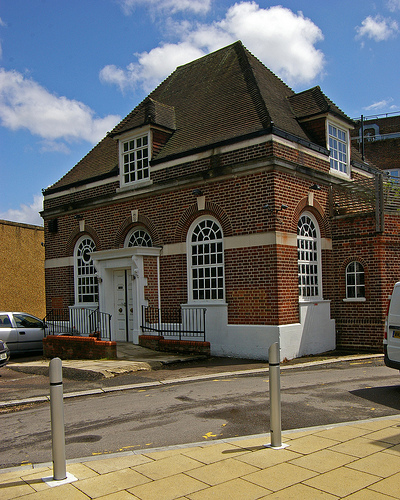<image>
Is the car in front of the building? Yes. The car is positioned in front of the building, appearing closer to the camera viewpoint. Where is the china glass in relation to the wood build? Is it in front of the wood build? No. The china glass is not in front of the wood build. The spatial positioning shows a different relationship between these objects. 